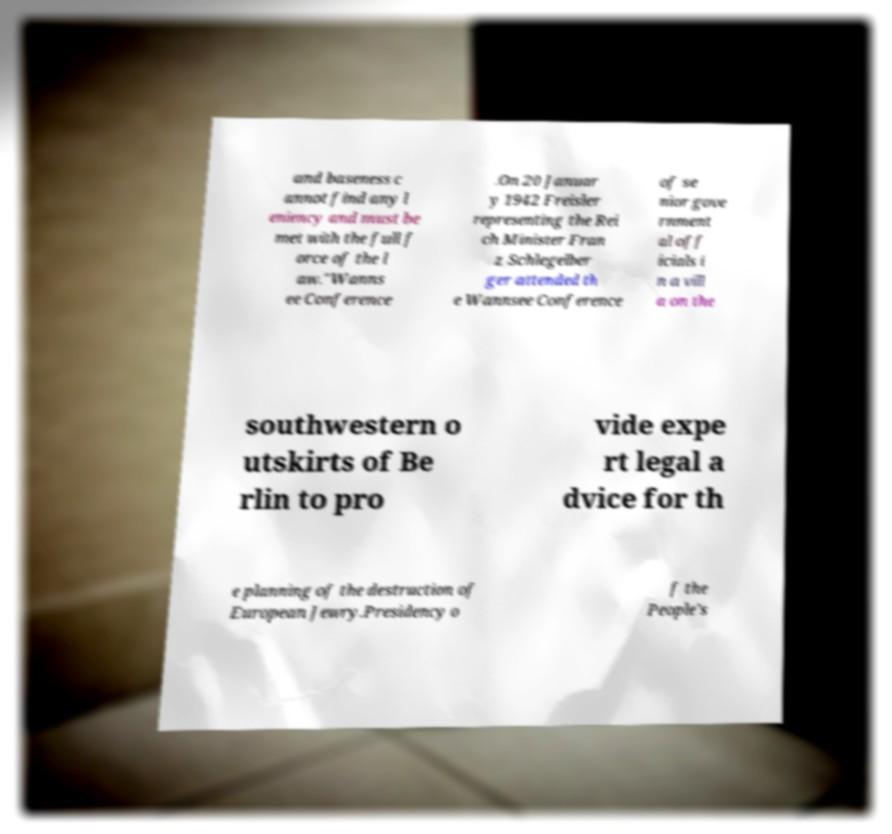Please read and relay the text visible in this image. What does it say? and baseness c annot find any l eniency and must be met with the full f orce of the l aw."Wanns ee Conference .On 20 Januar y 1942 Freisler representing the Rei ch Minister Fran z Schlegelber ger attended th e Wannsee Conference of se nior gove rnment al off icials i n a vill a on the southwestern o utskirts of Be rlin to pro vide expe rt legal a dvice for th e planning of the destruction of European Jewry.Presidency o f the People's 